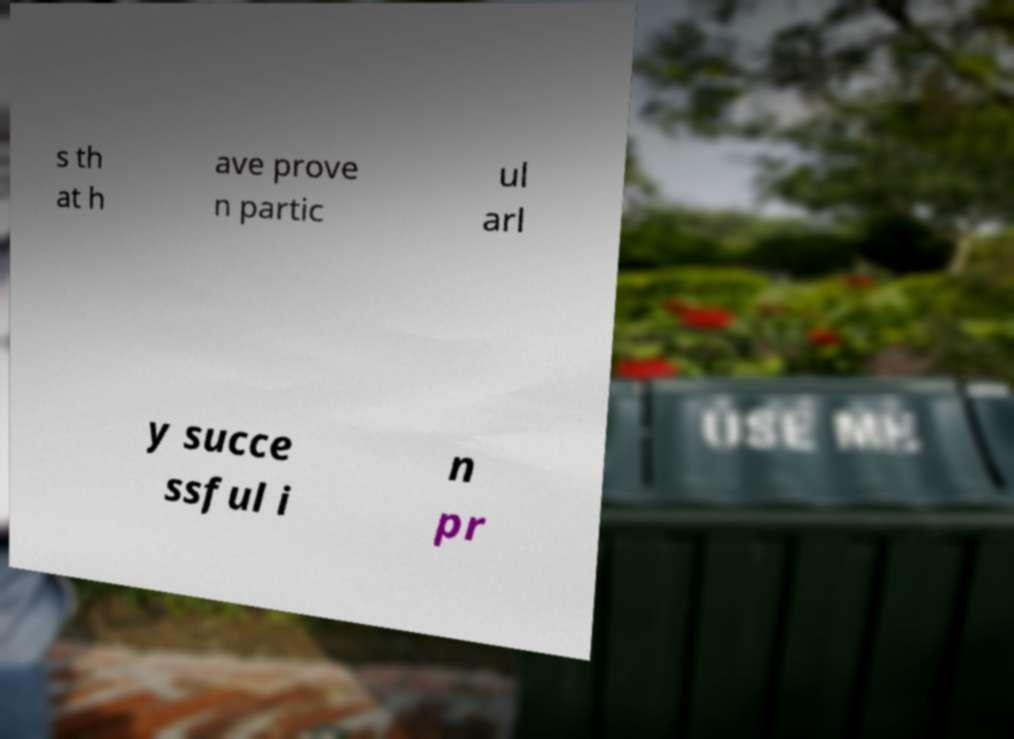Please read and relay the text visible in this image. What does it say? s th at h ave prove n partic ul arl y succe ssful i n pr 